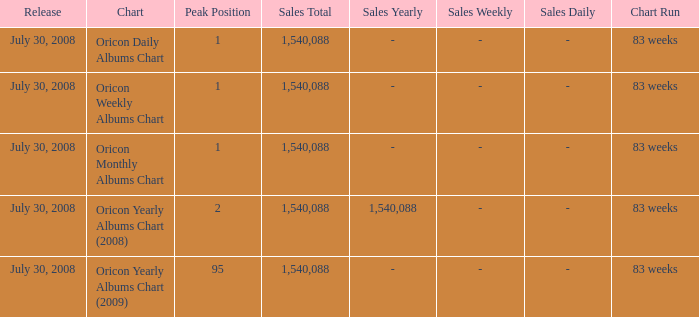Which Chart has a Peak Position of 1? Oricon Daily Albums Chart, Oricon Weekly Albums Chart, Oricon Monthly Albums Chart. 